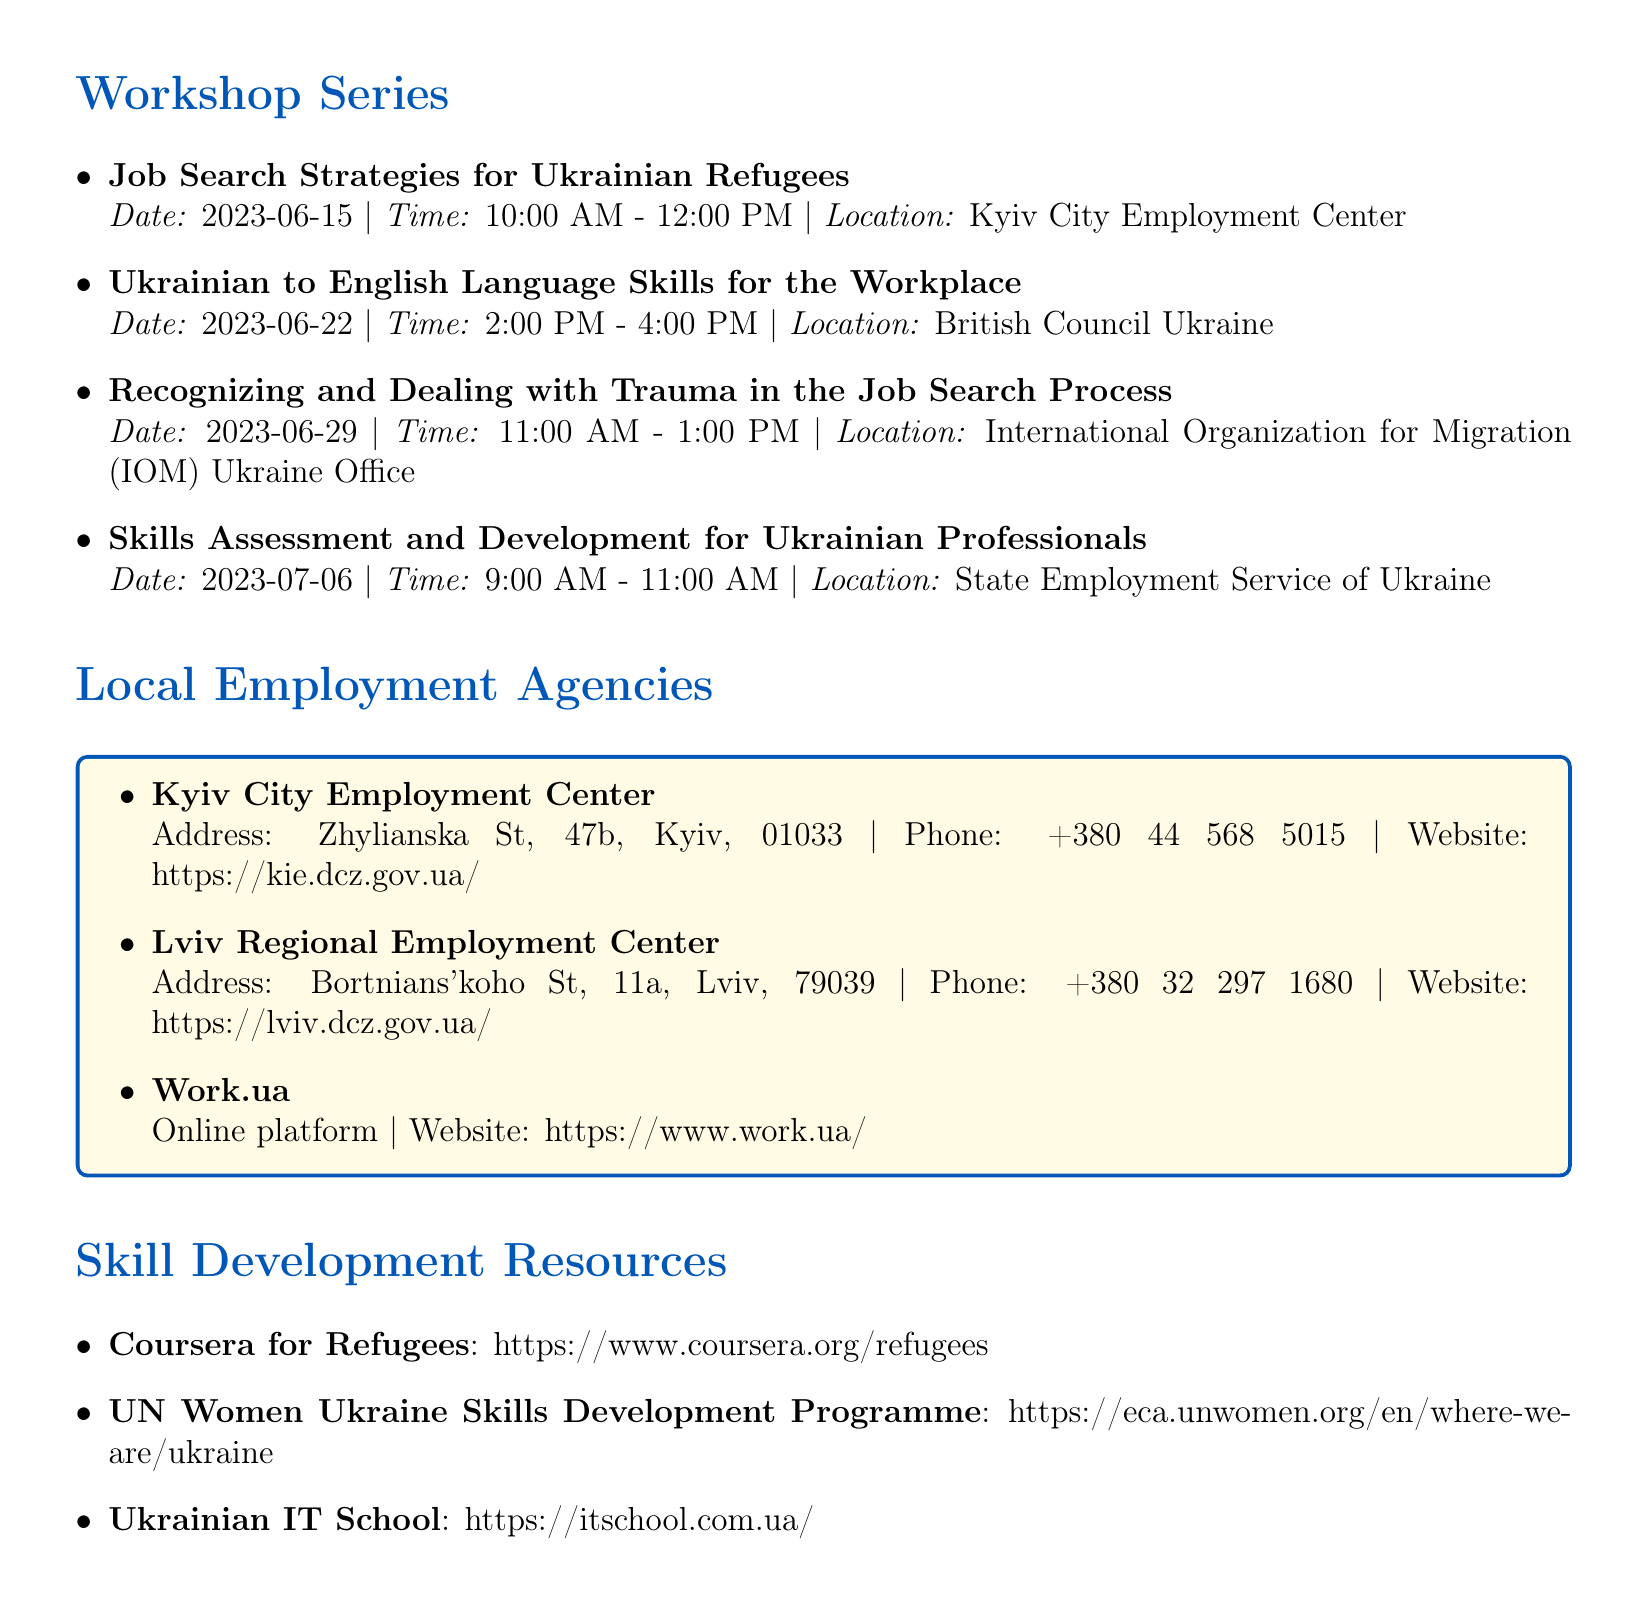what is the title of the first workshop? The title of the first workshop is listed directly in the document under the workshop series section.
Answer: Job Search Strategies for Ukrainian Refugees what is the date of the workshop on trauma in the job search process? The date can be found next to the title of the workshop in the document.
Answer: 2023-06-29 which agency provides job placement services? The services offered by local employment agencies are listed, and job placement is one of the services provided specifically at one agency.
Answer: Kyiv City Employment Center when does the skills assessment workshop take place? The date and time for the skills assessment workshop are explicitly mentioned in the workshop series section of the document.
Answer: 2023-07-06 what is the website for the Lviv Regional Employment Center? The website information for the Lviv Regional Employment Center is directly provided in the document.
Answer: https://lviv.dcz.gov.ua/ which organization offers psychological support services? Psychological support services are mentioned along with the organization providing them, which can be found in the specific sections.
Answer: UNHCR Mental Health and Psychosocial Support how long does the Ukrainian to English language workshop last? The duration of the workshop can be inferred from the time specified in the document.
Answer: 2 hours what is the address of the Kyiv City Employment Center? The address for the agency is listed directly in the document under the local employment agencies section.
Answer: Zhylianska St, 47b, Kyiv, 01033 what type of support does the UN Women Ukraine Skills Development Programme offer? The description of the skill development programme clarifies the type of support it provides, as outlined in the document.
Answer: Skill-building workshops and entrepreneurship support 